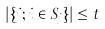<formula> <loc_0><loc_0><loc_500><loc_500>| \{ j ; i \in S _ { j } \} | \leq t</formula> 